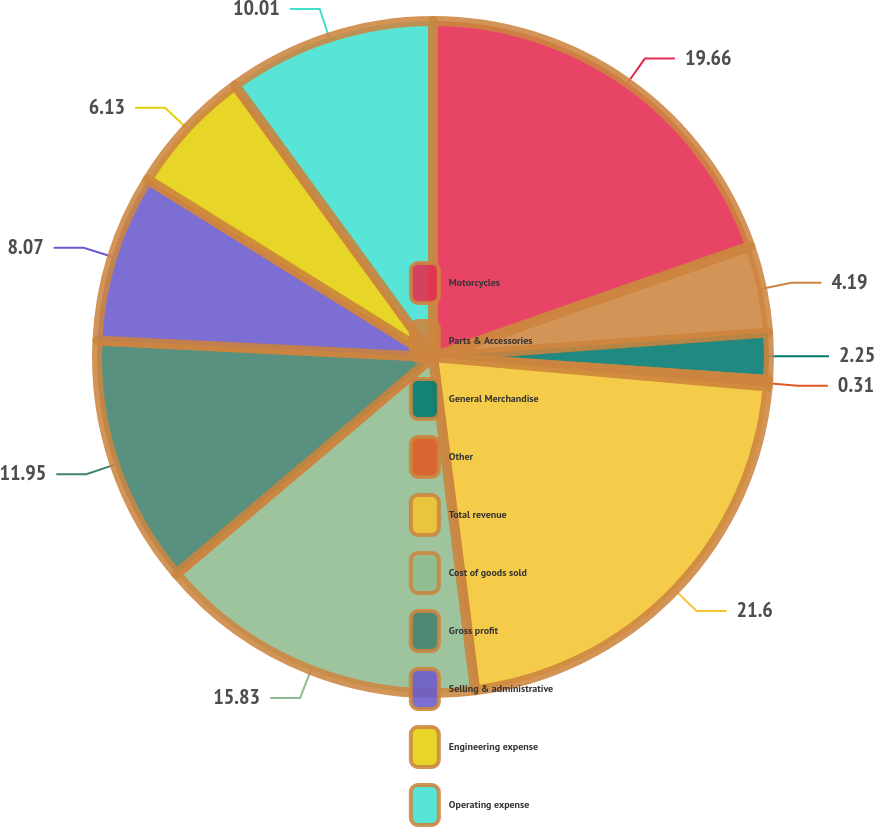<chart> <loc_0><loc_0><loc_500><loc_500><pie_chart><fcel>Motorcycles<fcel>Parts & Accessories<fcel>General Merchandise<fcel>Other<fcel>Total revenue<fcel>Cost of goods sold<fcel>Gross profit<fcel>Selling & administrative<fcel>Engineering expense<fcel>Operating expense<nl><fcel>19.65%<fcel>4.19%<fcel>2.25%<fcel>0.31%<fcel>21.59%<fcel>15.83%<fcel>11.95%<fcel>8.07%<fcel>6.13%<fcel>10.01%<nl></chart> 